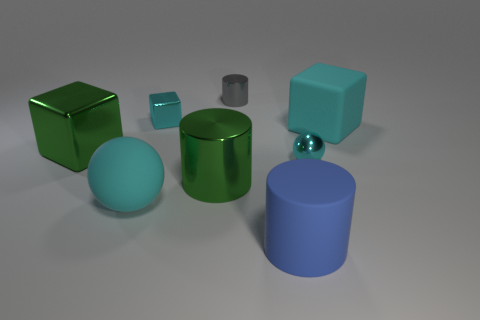Subtract all cyan cubes. How many were subtracted if there are1cyan cubes left? 1 Add 1 large red spheres. How many objects exist? 9 Subtract all balls. How many objects are left? 6 Subtract all big blue rubber cylinders. Subtract all small purple matte objects. How many objects are left? 7 Add 6 green metallic blocks. How many green metallic blocks are left? 7 Add 3 small yellow matte cylinders. How many small yellow matte cylinders exist? 3 Subtract 0 yellow balls. How many objects are left? 8 